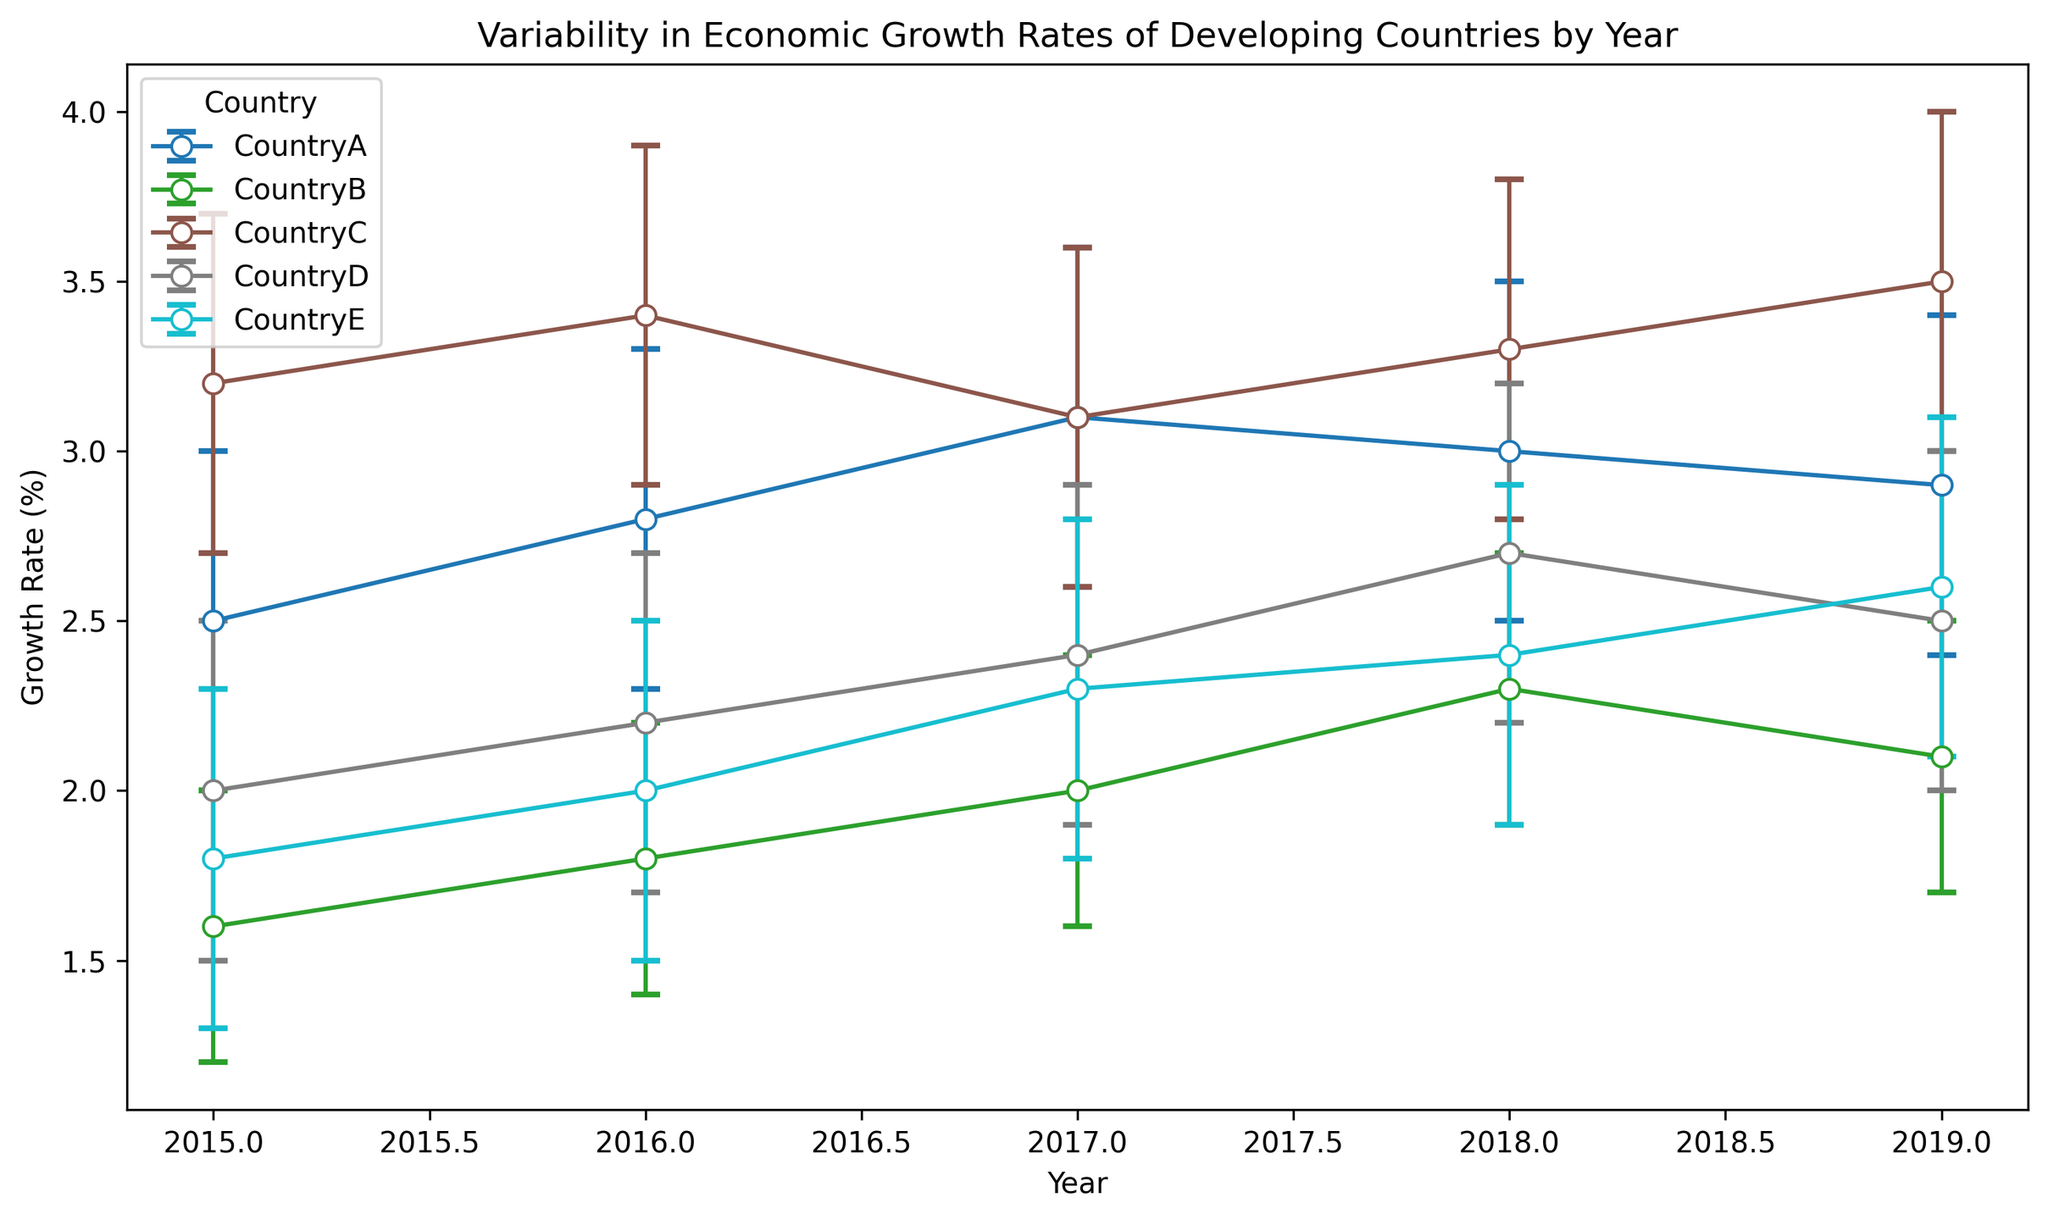Which country had the highest economic growth rate in 2019? Look for the highest point on the growth rate axis in 2019 among all the countries. Country C has the highest economic growth rate at 3.5% in 2019.
Answer: Country C Comparing Country A and Country B, which had a greater range of uncertainty in 2016? Determine the length of the error bars for both countries in 2016, which represents the range of uncertainty (UpperBound - LowerBound). For Country A, the range is 3.3 - 2.3 = 1.0. For Country B, it is 2.2 - 1.4 = 0.8. Country A has a greater range of uncertainty.
Answer: Country A What is the trend in economic growth rates for Country D from 2015 to 2019? Observe the direction of the connecting line for Country D from 2015 to 2019. The growth rates for Country D increase from 2.0 in 2015 to 2.7 in 2018, then slightly decrease to 2.5 in 2019.
Answer: Increasing until 2018, then decreasing in 2019 Which country shows the most consistent growth rate between 2015 and 2019? Look for the country with the least variation in growth rates over the years. Country C's growth rates range from 3.1 to 3.5, showing the least fluctuation.
Answer: Country C By how much did the growth rate of Country E increase from 2015 to 2019? Subtract the growth rate of Country E in 2015 from its growth rate in 2019. The growth rate in 2019 is 2.6 and in 2015 it was 1.8. Therefore, 2.6 - 1.8 = 0.8.
Answer: 0.8 Which two countries had overlapping uncertainty bounds in 2017? Identify the years where the error bars for different countries overlap. In 2017, the uncertainty bounds of Country A (2.6 to 3.6) and Country C (2.6 to 3.6) overlap.
Answer: Country A and Country C On average, what was Country B's growth rate across the given years? Calculate the mean of Country B's growth rates from 2015 to 2019. The growth rates are 1.6, 1.8, 2.0, 2.3, and 2.1. The sum is 9.8, and there are 5 years. Therefore, 9.8 / 5 = 1.96.
Answer: 1.96 Which country had the most significant jump in growth rate between two consecutive years? Determine the difference in growth rates between consecutive years for each country, then find the largest difference. Country E had a significant jump from 2017 (2.3) to 2018 (2.4), but it's comparatively smaller than the jump of Country B from 2017 (2.0) to 2018 (2.3).
Answer: Country B What is the highest point representing an economic growth rate in the plot? Identify the highest point on the growth rate axis across all years and countries. Country C in 2019 has the highest growth rate marker at 3.5.
Answer: 3.5 